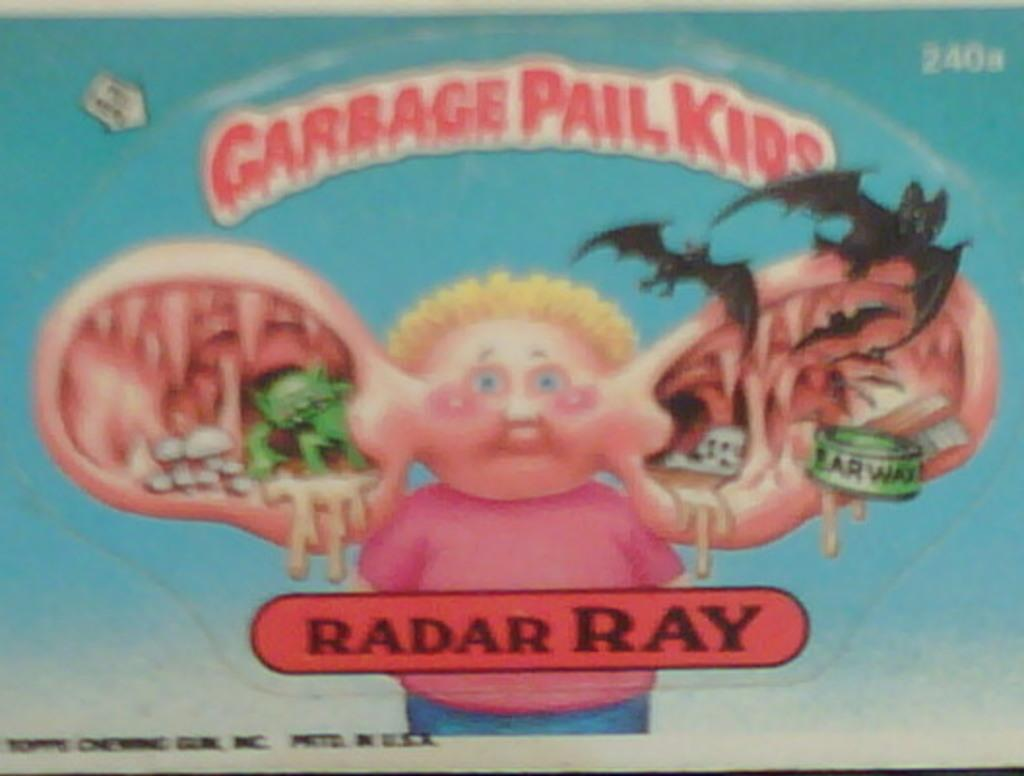Provide a one-sentence caption for the provided image. garbage pail kids by radar ray book with a kids. 